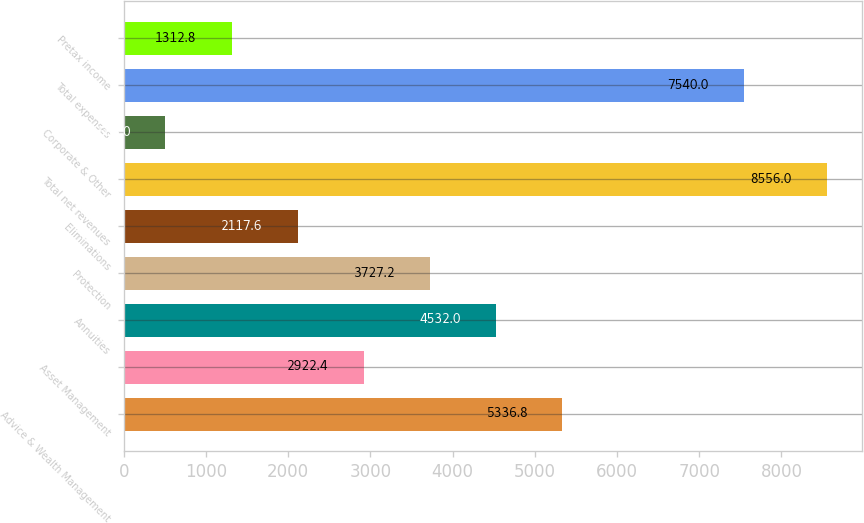<chart> <loc_0><loc_0><loc_500><loc_500><bar_chart><fcel>Advice & Wealth Management<fcel>Asset Management<fcel>Annuities<fcel>Protection<fcel>Eliminations<fcel>Total net revenues<fcel>Corporate & Other<fcel>Total expenses<fcel>Pretax income<nl><fcel>5336.8<fcel>2922.4<fcel>4532<fcel>3727.2<fcel>2117.6<fcel>8556<fcel>508<fcel>7540<fcel>1312.8<nl></chart> 